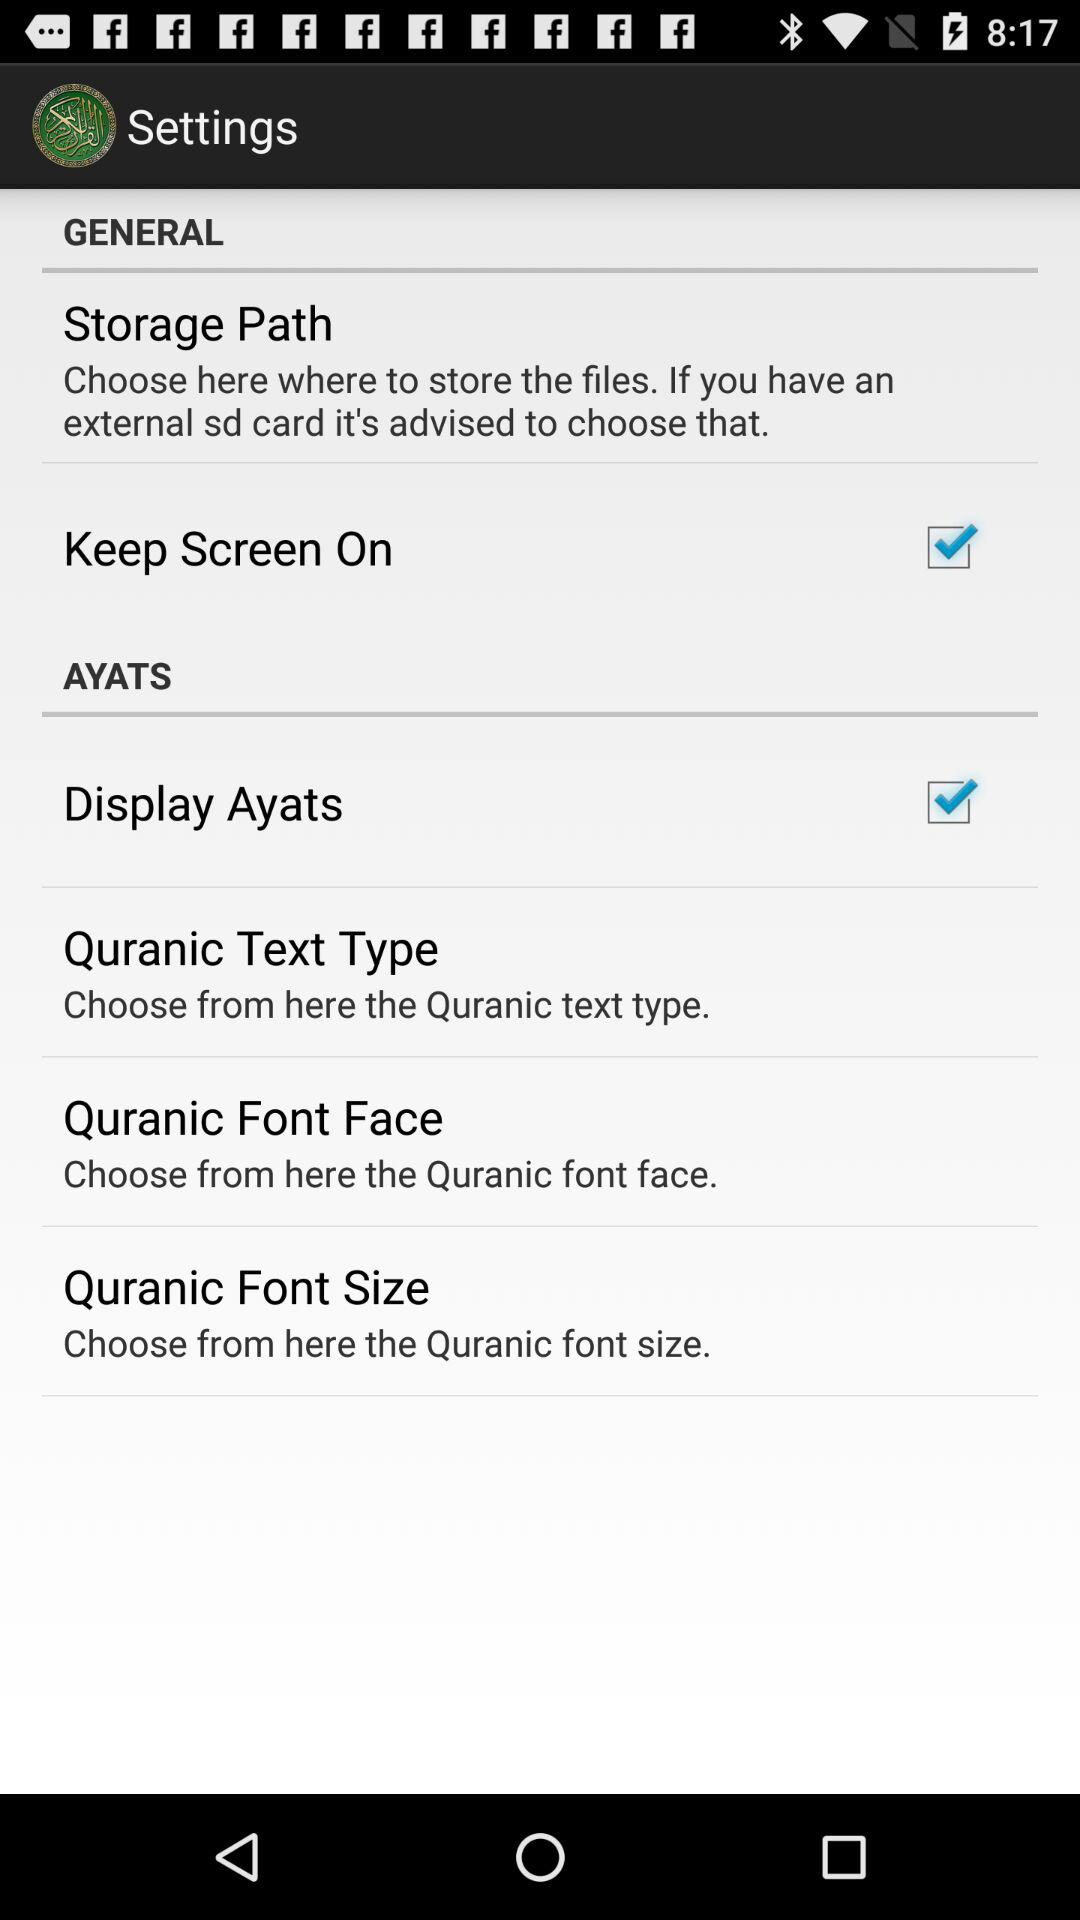What is the status of "Display Ayats"? The status of "Display Ayats" is "on". 